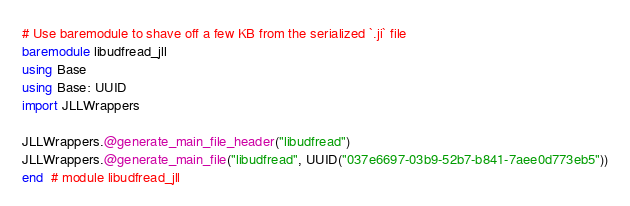<code> <loc_0><loc_0><loc_500><loc_500><_Julia_># Use baremodule to shave off a few KB from the serialized `.ji` file
baremodule libudfread_jll
using Base
using Base: UUID
import JLLWrappers

JLLWrappers.@generate_main_file_header("libudfread")
JLLWrappers.@generate_main_file("libudfread", UUID("037e6697-03b9-52b7-b841-7aee0d773eb5"))
end  # module libudfread_jll
</code> 